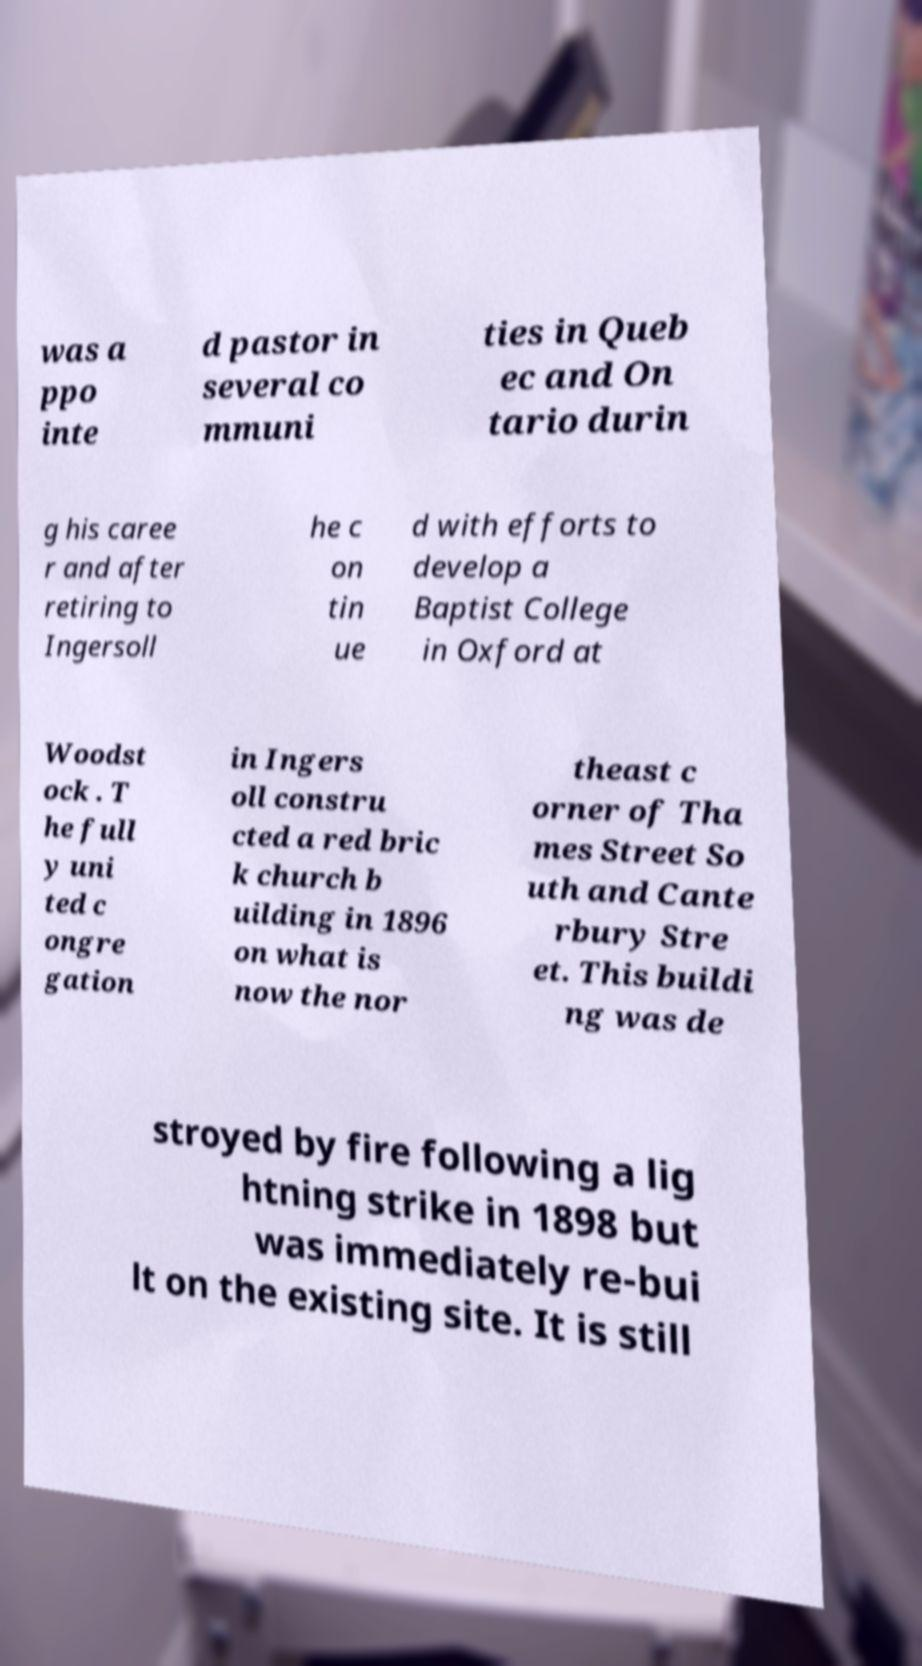Can you read and provide the text displayed in the image?This photo seems to have some interesting text. Can you extract and type it out for me? was a ppo inte d pastor in several co mmuni ties in Queb ec and On tario durin g his caree r and after retiring to Ingersoll he c on tin ue d with efforts to develop a Baptist College in Oxford at Woodst ock . T he full y uni ted c ongre gation in Ingers oll constru cted a red bric k church b uilding in 1896 on what is now the nor theast c orner of Tha mes Street So uth and Cante rbury Stre et. This buildi ng was de stroyed by fire following a lig htning strike in 1898 but was immediately re-bui lt on the existing site. It is still 